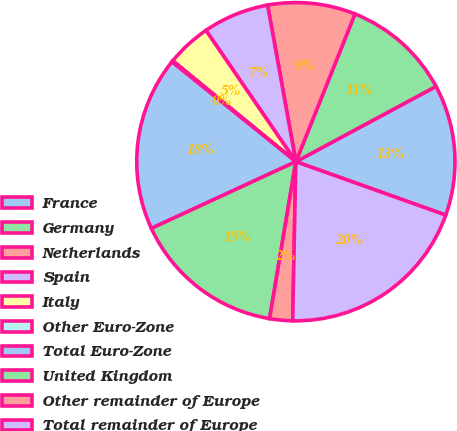Convert chart to OTSL. <chart><loc_0><loc_0><loc_500><loc_500><pie_chart><fcel>France<fcel>Germany<fcel>Netherlands<fcel>Spain<fcel>Italy<fcel>Other Euro-Zone<fcel>Total Euro-Zone<fcel>United Kingdom<fcel>Other remainder of Europe<fcel>Total remainder of Europe<nl><fcel>13.29%<fcel>11.1%<fcel>8.9%<fcel>6.71%<fcel>4.52%<fcel>0.13%<fcel>17.68%<fcel>15.48%<fcel>2.32%<fcel>19.87%<nl></chart> 